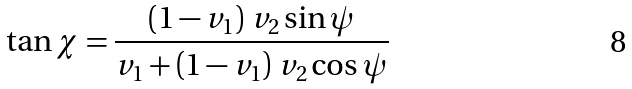Convert formula to latex. <formula><loc_0><loc_0><loc_500><loc_500>\tan \chi = \frac { \left ( 1 - v _ { 1 } \right ) \, v _ { 2 } \sin \psi } { v _ { 1 } + \left ( 1 - v _ { 1 } \right ) \, v _ { 2 } \cos \psi }</formula> 